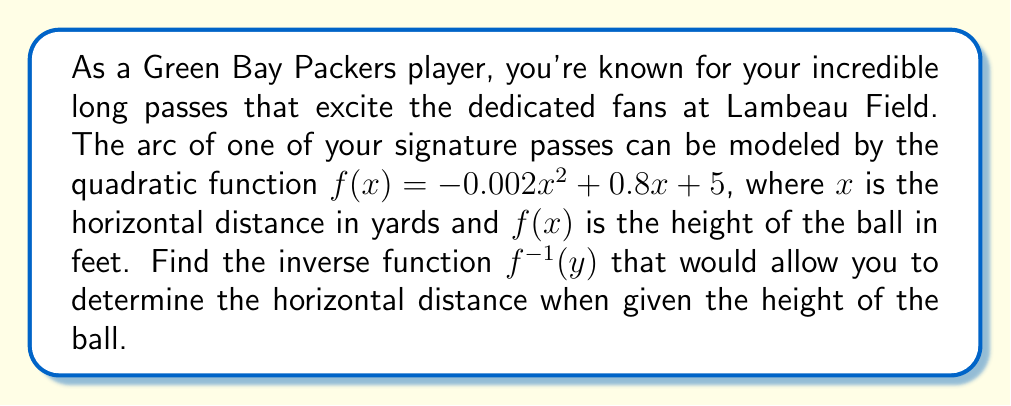Teach me how to tackle this problem. To find the inverse of the quadratic function, we'll follow these steps:

1) Start with the original function:
   $y = -0.002x^2 + 0.8x + 5$

2) Swap $x$ and $y$:
   $x = -0.002y^2 + 0.8y + 5$

3) Rearrange the equation to standard form $ay^2 + by + c = 0$:
   $-0.002y^2 + 0.8y + (5 - x) = 0$

4) Use the quadratic formula to solve for $y$:
   $y = \frac{-b \pm \sqrt{b^2 - 4ac}}{2a}$

   Where $a = -0.002$, $b = 0.8$, and $c = 5 - x$

5) Substitute these values into the quadratic formula:
   $y = \frac{-0.8 \pm \sqrt{0.8^2 - 4(-0.002)(5-x)}}{2(-0.002)}$

6) Simplify:
   $y = \frac{-0.8 \pm \sqrt{0.64 + 0.008(x-5)}}{-0.004}$
   $y = \frac{-0.8 \pm \sqrt{0.64 + 0.008x - 0.04}}{-0.004}$
   $y = \frac{-0.8 \pm \sqrt{0.6 + 0.008x}}{-0.004}$

7) The positive root is the one we want, as it corresponds to the upward arc of the pass:
   $y = \frac{-0.8 + \sqrt{0.6 + 0.008x}}{-0.004}$

8) Simplify by multiplying numerator and denominator by -1:
   $y = \frac{0.8 - \sqrt{0.6 + 0.008x}}{0.004}$

9) This is the inverse function. Replace $y$ with $f^{-1}(x)$ for proper notation:
   $f^{-1}(x) = \frac{0.8 - \sqrt{0.6 + 0.008x}}{0.004}$
Answer: $f^{-1}(x) = \frac{0.8 - \sqrt{0.6 + 0.008x}}{0.004}$ 